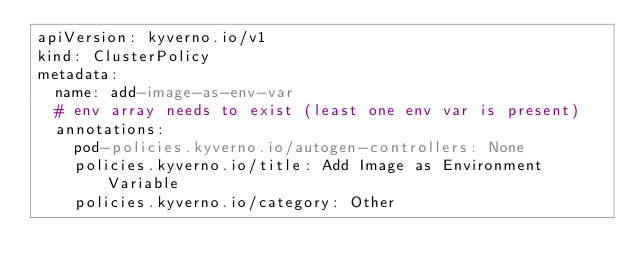Convert code to text. <code><loc_0><loc_0><loc_500><loc_500><_YAML_>apiVersion: kyverno.io/v1
kind: ClusterPolicy
metadata:
  name: add-image-as-env-var
  # env array needs to exist (least one env var is present)
  annotations:
    pod-policies.kyverno.io/autogen-controllers: None
    policies.kyverno.io/title: Add Image as Environment Variable
    policies.kyverno.io/category: Other</code> 